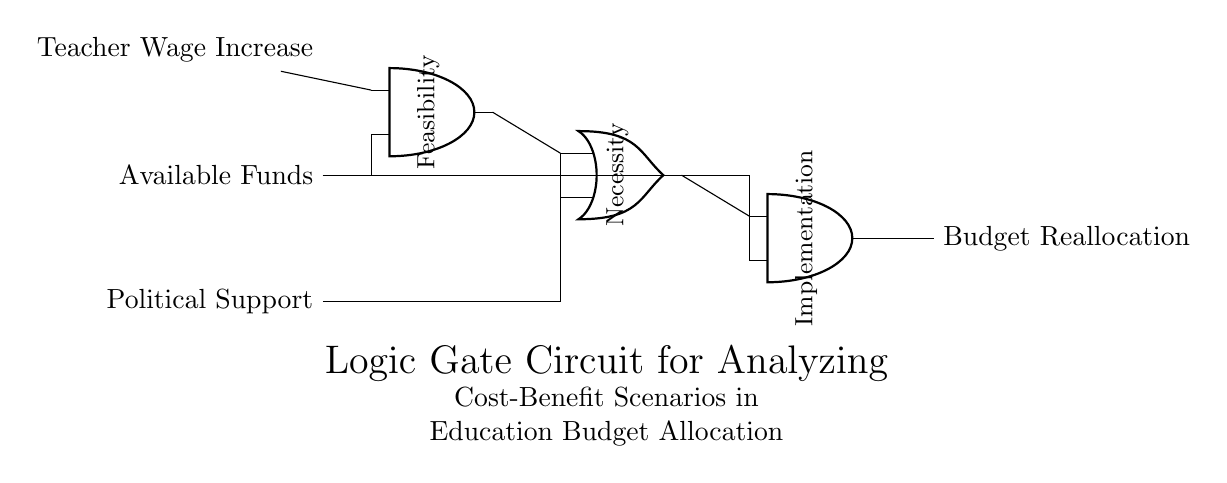What are the inputs to the circuit? The inputs to the circuit are "Teacher Wage Increase", "Available Funds", and "Political Support", which are the three nodes on the left side of the diagram.
Answer: Teacher Wage Increase, Available Funds, Political Support What type of logic gates are used in the circuit? There are two types of logic gates used in the circuit: AND gates and an OR gate. The circuit has two AND gates and one OR gate among its components.
Answer: AND, OR What is the purpose of the AND gate labeled "Feasibility"? The AND gate labeled "Feasibility" assesses whether both "Teacher Wage Increase" and "Available Funds" are present, indicating that a wage increase might be feasible if there are enough funds.
Answer: To assess feasibility What output results from the AND gate labeled "Implementation"? The output from the "Implementation" AND gate is "Budget Reallocation", indicating that the conditions required for reallocating the budget based on previous inputs are satisfied.
Answer: Budget Reallocation Which two conditions must be met for the "Budget Reallocation" output to occur? The output "Budget Reallocation" can only occur if both outputs from the OR gate (either "Political Support" or the output from "Feasibility") and "Available Funds" are true, meaning all necessary support and funds conditions are satisfied.
Answer: Feasibility and Available Funds What does the OR gate labeled "Necessity" signify in the circuit? The OR gate labeled "Necessity" signifies that either "Political Support" or the outcome of the "Feasibility" AND gate can influence the next stage of processing, depicting a condition where at least one of these factors is necessary for consideration.
Answer: Political Support or Feasibility 